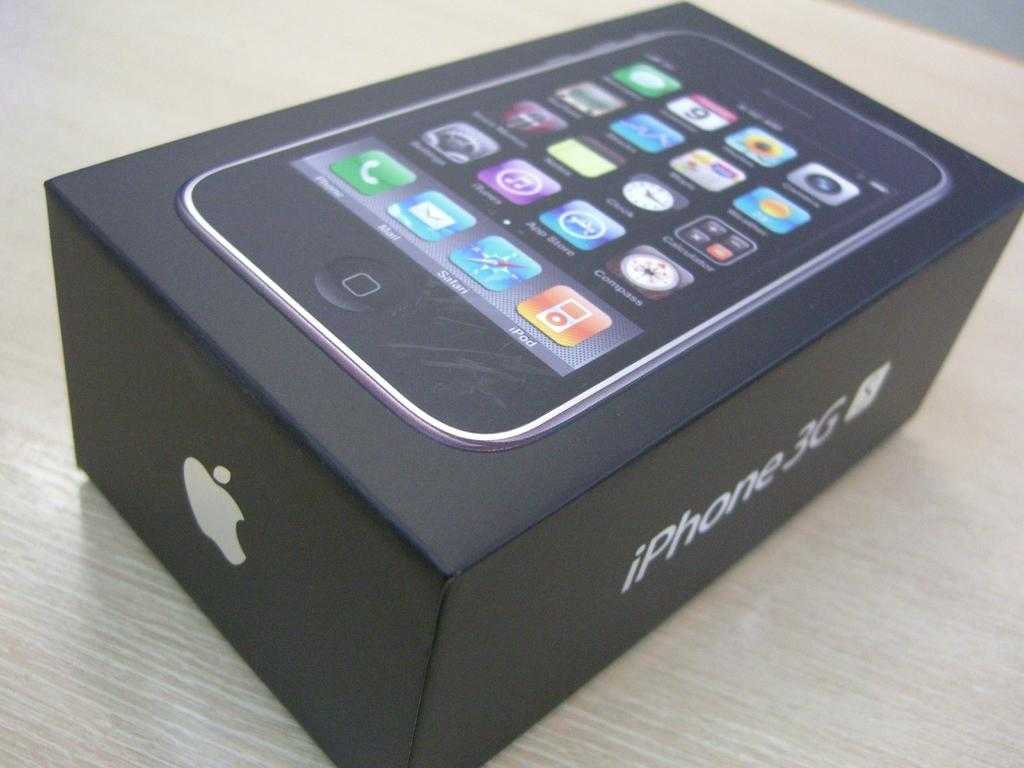<image>
Render a clear and concise summary of the photo. A black box for the Apple iPhone 3G with colorful icons on the top of the box. 